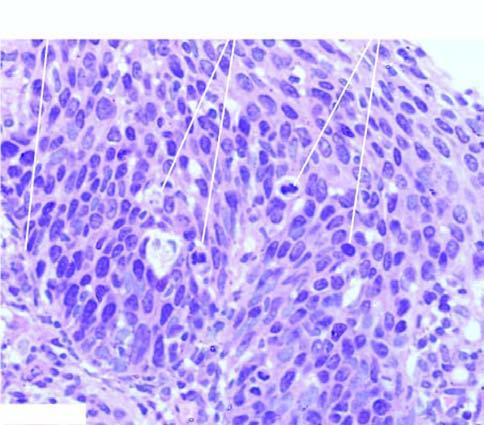what are confined to all the layers of the mucosa but the basement membrane on which these layers rest is intact?
Answer the question using a single word or phrase. Atypical dysplastic squamous cells 